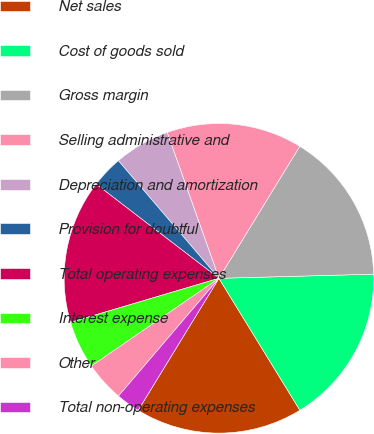Convert chart. <chart><loc_0><loc_0><loc_500><loc_500><pie_chart><fcel>Net sales<fcel>Cost of goods sold<fcel>Gross margin<fcel>Selling administrative and<fcel>Depreciation and amortization<fcel>Provision for doubtful<fcel>Total operating expenses<fcel>Interest expense<fcel>Other<fcel>Total non-operating expenses<nl><fcel>17.5%<fcel>16.67%<fcel>15.83%<fcel>14.17%<fcel>5.83%<fcel>3.33%<fcel>15.0%<fcel>5.0%<fcel>4.17%<fcel>2.5%<nl></chart> 